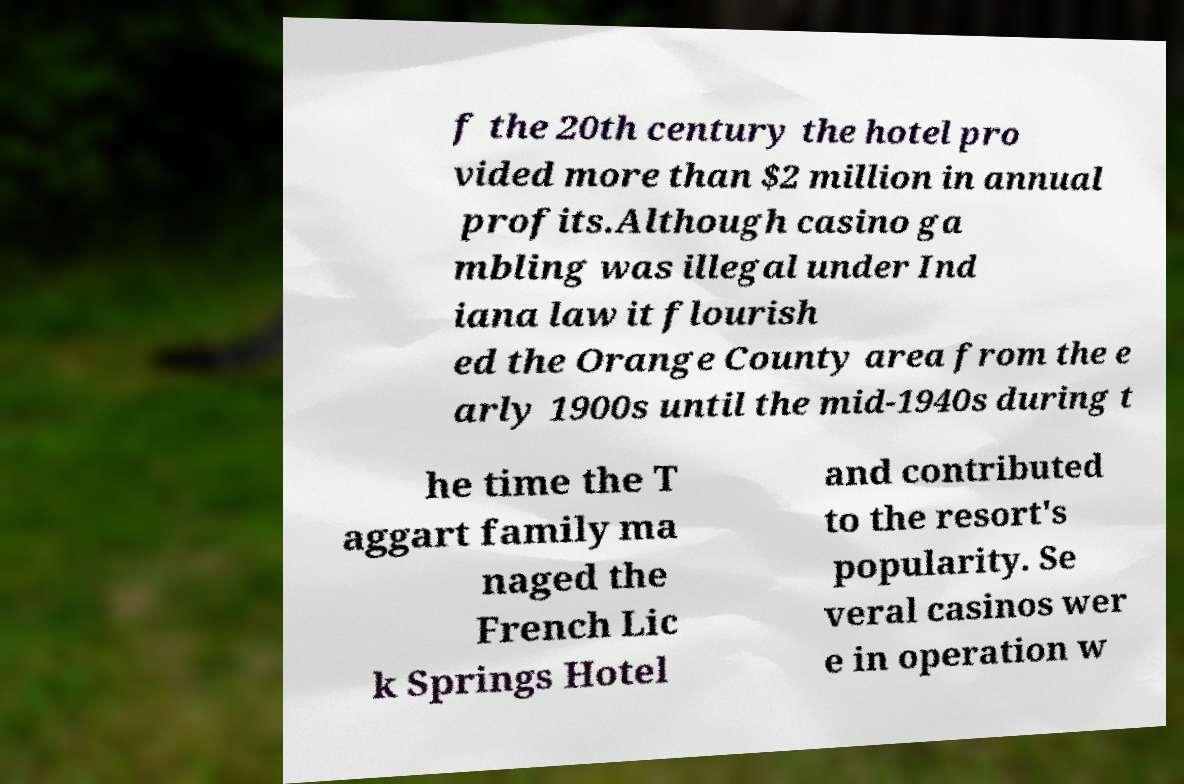There's text embedded in this image that I need extracted. Can you transcribe it verbatim? f the 20th century the hotel pro vided more than $2 million in annual profits.Although casino ga mbling was illegal under Ind iana law it flourish ed the Orange County area from the e arly 1900s until the mid-1940s during t he time the T aggart family ma naged the French Lic k Springs Hotel and contributed to the resort's popularity. Se veral casinos wer e in operation w 